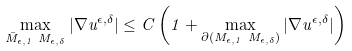<formula> <loc_0><loc_0><loc_500><loc_500>\max _ { \bar { M } _ { \epsilon , 1 } \ M _ { \epsilon , \delta } } | \nabla u ^ { \epsilon , \delta } | \leq C \left ( 1 + \max _ { \partial ( { M } _ { \epsilon , 1 } \ M _ { \epsilon , \delta } ) } | \nabla u ^ { \epsilon , \delta } | \right )</formula> 